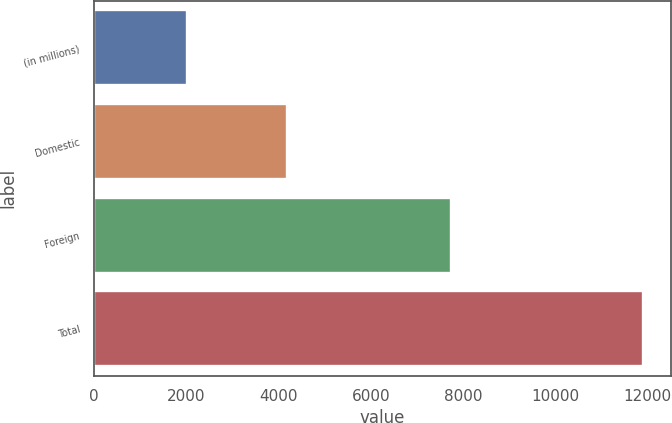<chart> <loc_0><loc_0><loc_500><loc_500><bar_chart><fcel>(in millions)<fcel>Domestic<fcel>Foreign<fcel>Total<nl><fcel>2003<fcel>4177<fcel>7730<fcel>11907<nl></chart> 